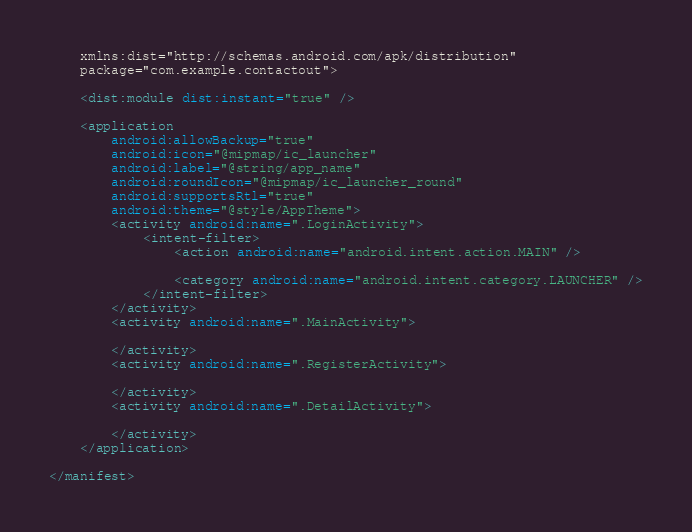Convert code to text. <code><loc_0><loc_0><loc_500><loc_500><_XML_>    xmlns:dist="http://schemas.android.com/apk/distribution"
    package="com.example.contactout">

    <dist:module dist:instant="true" />

    <application
        android:allowBackup="true"
        android:icon="@mipmap/ic_launcher"
        android:label="@string/app_name"
        android:roundIcon="@mipmap/ic_launcher_round"
        android:supportsRtl="true"
        android:theme="@style/AppTheme">
        <activity android:name=".LoginActivity">
            <intent-filter>
                <action android:name="android.intent.action.MAIN" />

                <category android:name="android.intent.category.LAUNCHER" />
            </intent-filter>
        </activity>
        <activity android:name=".MainActivity">

        </activity>
        <activity android:name=".RegisterActivity">

        </activity>
        <activity android:name=".DetailActivity">

        </activity>
    </application>

</manifest></code> 